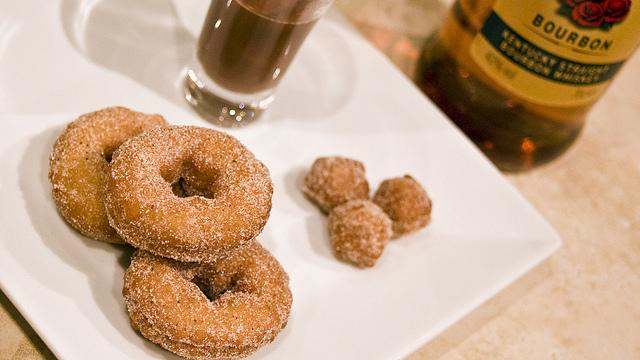What food is next to the doughnuts?
Quick response, please. Donut holes. Does the beverage contain alcohol?
Keep it brief. Yes. How many donuts are pictured here?
Short answer required. 3. What flower is on the bottle?
Short answer required. Rose. 